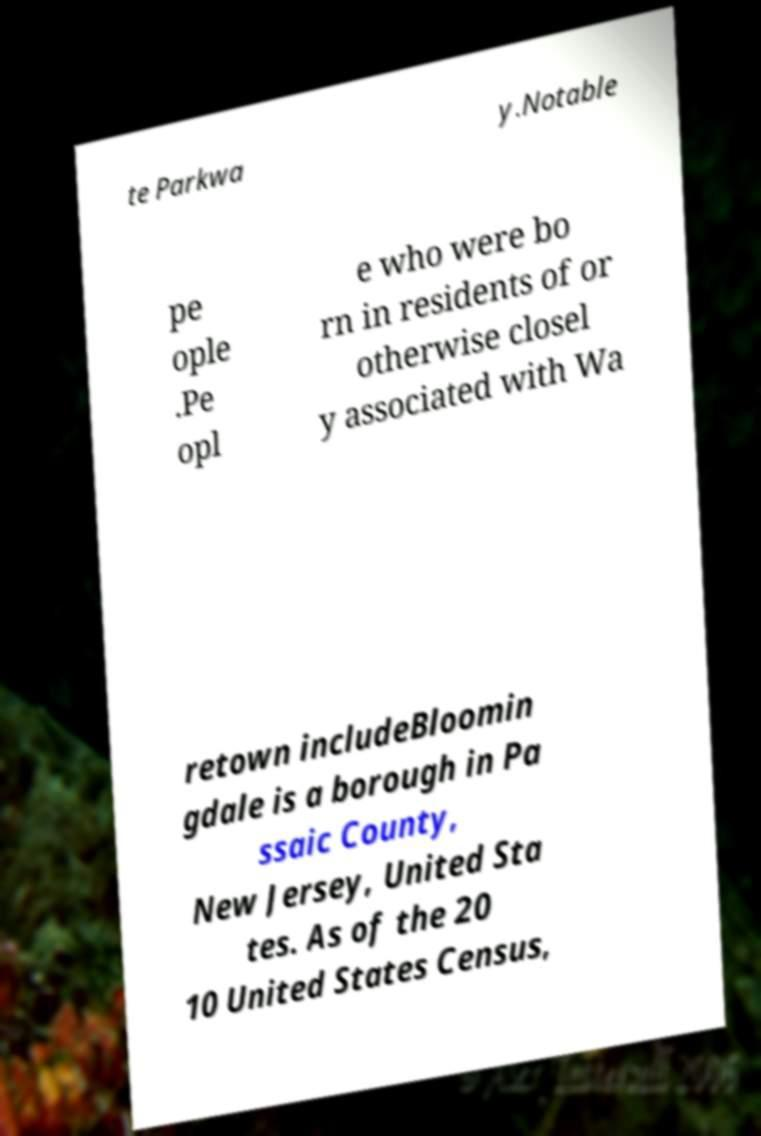Can you read and provide the text displayed in the image?This photo seems to have some interesting text. Can you extract and type it out for me? te Parkwa y.Notable pe ople .Pe opl e who were bo rn in residents of or otherwise closel y associated with Wa retown includeBloomin gdale is a borough in Pa ssaic County, New Jersey, United Sta tes. As of the 20 10 United States Census, 